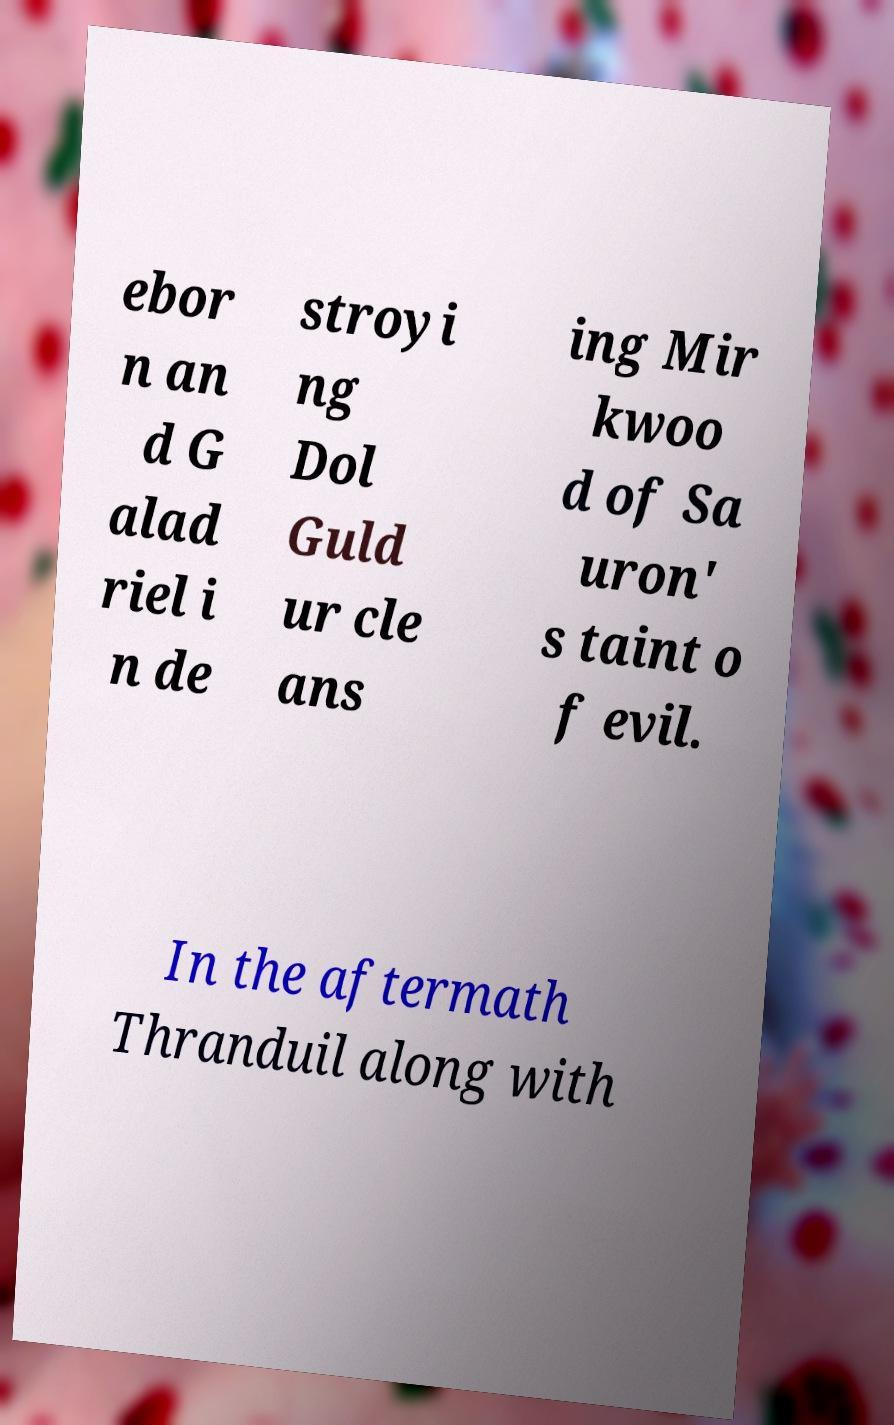Please identify and transcribe the text found in this image. ebor n an d G alad riel i n de stroyi ng Dol Guld ur cle ans ing Mir kwoo d of Sa uron' s taint o f evil. In the aftermath Thranduil along with 